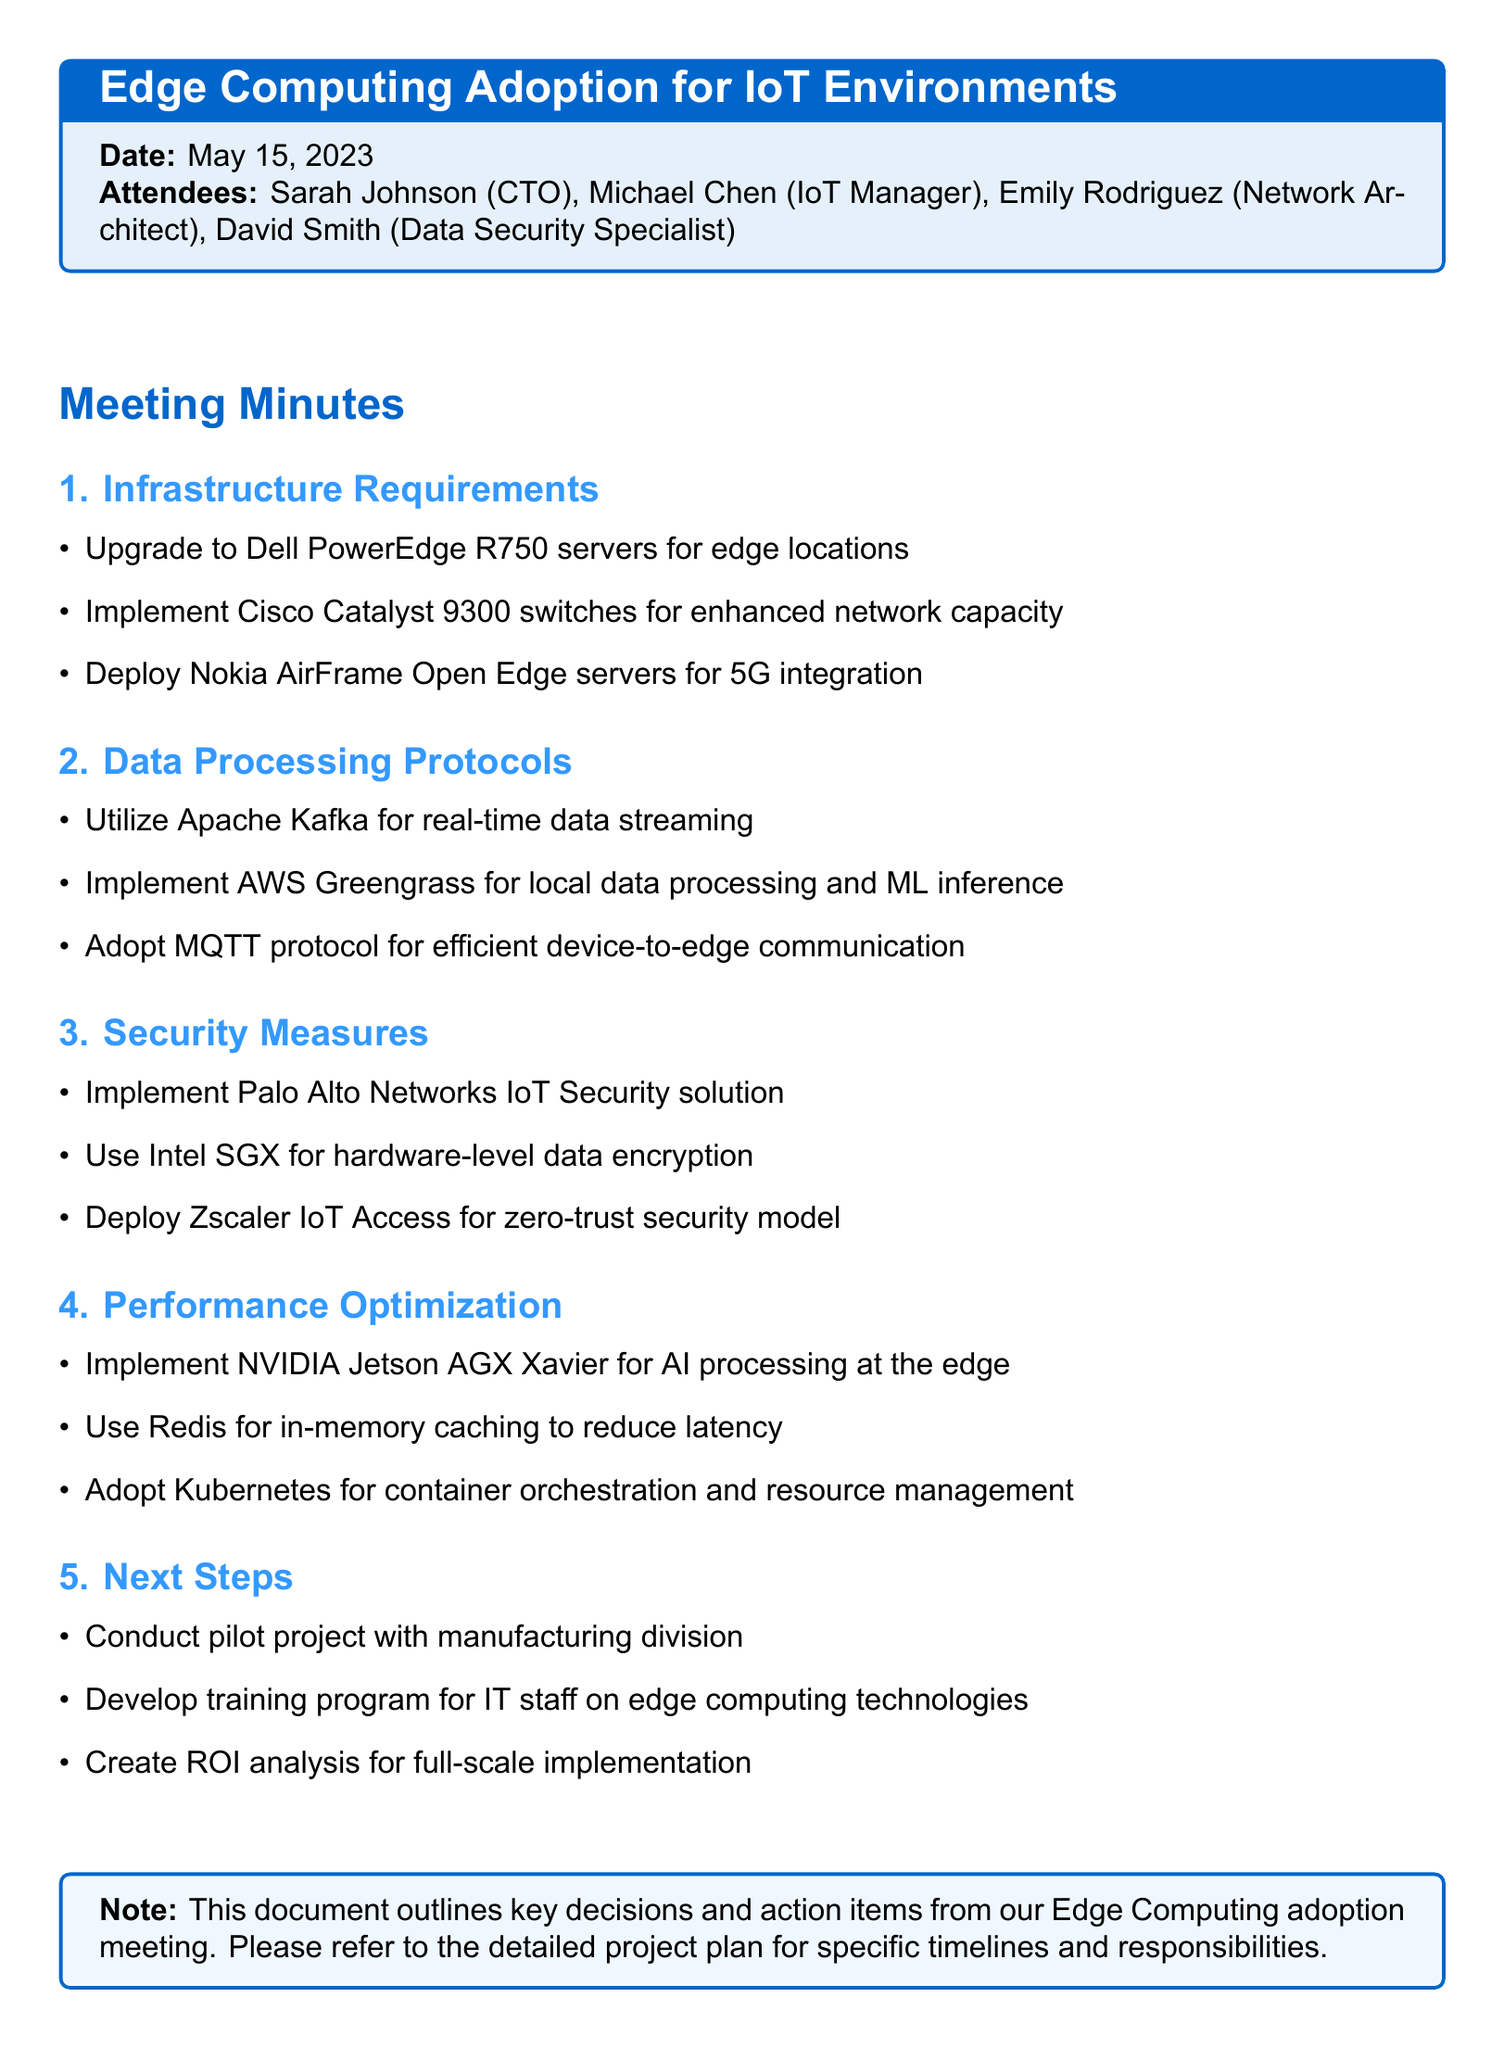What is the meeting title? The meeting title is specified at the beginning of the document, which is "Edge Computing Adoption for IoT Environments."
Answer: Edge Computing Adoption for IoT Environments Who is the IoT Manager? The document lists the attendees, including Michael Chen as the IoT Manager.
Answer: Michael Chen What servers are suggested for edge locations? The infrastructure requirements include upgrading to Dell PowerEdge R750 servers for edge locations.
Answer: Dell PowerEdge R750 Which protocol is adopted for efficient device-to-edge communication? The data processing protocols section mentions adopting the MQTT protocol for efficient device-to-edge communication.
Answer: MQTT How many attendees were present at the meeting? The document lists four attendees present at the meeting.
Answer: Four What is one of the next steps identified in the meeting? The next steps section outlines several items, one of which is to conduct a pilot project with the manufacturing division.
Answer: Conduct pilot project with manufacturing division What solution is implemented for hardware-level data encryption? The security measures include using Intel SGX for hardware-level data encryption.
Answer: Intel SGX Which technology is suggested for AI processing at the edge? The performance optimization section suggests implementing NVIDIA Jetson AGX Xavier for AI processing at the edge.
Answer: NVIDIA Jetson AGX Xavier 